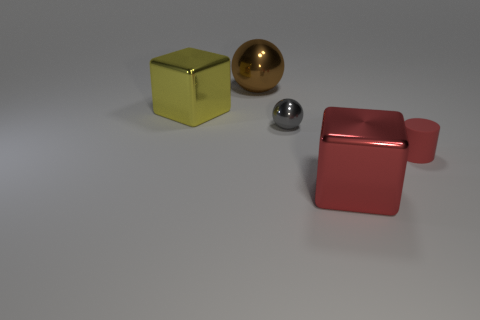Is there anything else that has the same shape as the tiny rubber object?
Keep it short and to the point. No. There is a object that is left of the large brown metallic thing; what shape is it?
Offer a very short reply. Cube. There is a large ball that is made of the same material as the small gray sphere; what color is it?
Your answer should be very brief. Brown. There is another large object that is the same shape as the yellow metallic thing; what is it made of?
Make the answer very short. Metal. There is a brown thing; what shape is it?
Offer a very short reply. Sphere. What is the object that is behind the small red thing and to the right of the large sphere made of?
Offer a very short reply. Metal. The big yellow thing that is the same material as the gray object is what shape?
Keep it short and to the point. Cube. The yellow cube that is made of the same material as the big brown object is what size?
Your answer should be compact. Large. There is a large metal object that is both on the left side of the red metallic object and right of the large yellow metallic object; what shape is it?
Make the answer very short. Sphere. There is a metal cube that is in front of the cylinder that is to the right of the small gray metallic ball; how big is it?
Ensure brevity in your answer.  Large. 